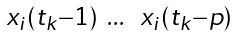Convert formula to latex. <formula><loc_0><loc_0><loc_500><loc_500>\begin{smallmatrix} x _ { i } ( t _ { k } - 1 ) & \dots & x _ { i } ( t _ { k } - p ) \end{smallmatrix}</formula> 